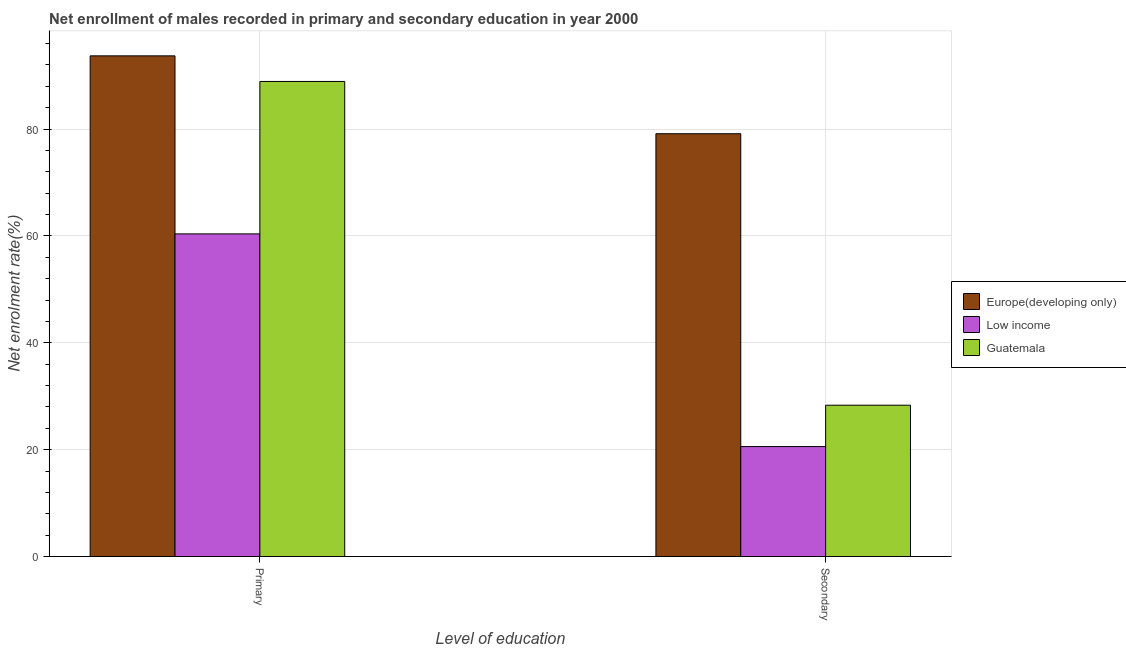Are the number of bars on each tick of the X-axis equal?
Make the answer very short. Yes. How many bars are there on the 1st tick from the left?
Provide a succinct answer. 3. How many bars are there on the 2nd tick from the right?
Provide a succinct answer. 3. What is the label of the 2nd group of bars from the left?
Give a very brief answer. Secondary. What is the enrollment rate in secondary education in Europe(developing only)?
Your response must be concise. 79.12. Across all countries, what is the maximum enrollment rate in primary education?
Offer a very short reply. 93.69. Across all countries, what is the minimum enrollment rate in primary education?
Offer a very short reply. 60.37. In which country was the enrollment rate in secondary education maximum?
Your response must be concise. Europe(developing only). What is the total enrollment rate in primary education in the graph?
Provide a succinct answer. 242.96. What is the difference between the enrollment rate in primary education in Europe(developing only) and that in Low income?
Provide a succinct answer. 33.31. What is the difference between the enrollment rate in primary education in Guatemala and the enrollment rate in secondary education in Low income?
Provide a succinct answer. 68.32. What is the average enrollment rate in primary education per country?
Your response must be concise. 80.99. What is the difference between the enrollment rate in primary education and enrollment rate in secondary education in Guatemala?
Offer a terse response. 60.58. In how many countries, is the enrollment rate in secondary education greater than 56 %?
Keep it short and to the point. 1. What is the ratio of the enrollment rate in primary education in Guatemala to that in Low income?
Make the answer very short. 1.47. Is the enrollment rate in primary education in Low income less than that in Europe(developing only)?
Provide a succinct answer. Yes. What does the 3rd bar from the left in Secondary represents?
Your answer should be very brief. Guatemala. What does the 3rd bar from the right in Secondary represents?
Offer a very short reply. Europe(developing only). How many bars are there?
Your answer should be very brief. 6. Are all the bars in the graph horizontal?
Provide a succinct answer. No. How many countries are there in the graph?
Provide a short and direct response. 3. Does the graph contain grids?
Your response must be concise. Yes. What is the title of the graph?
Your answer should be very brief. Net enrollment of males recorded in primary and secondary education in year 2000. What is the label or title of the X-axis?
Offer a terse response. Level of education. What is the label or title of the Y-axis?
Give a very brief answer. Net enrolment rate(%). What is the Net enrolment rate(%) of Europe(developing only) in Primary?
Offer a terse response. 93.69. What is the Net enrolment rate(%) in Low income in Primary?
Make the answer very short. 60.37. What is the Net enrolment rate(%) of Guatemala in Primary?
Give a very brief answer. 88.9. What is the Net enrolment rate(%) in Europe(developing only) in Secondary?
Provide a short and direct response. 79.12. What is the Net enrolment rate(%) of Low income in Secondary?
Make the answer very short. 20.57. What is the Net enrolment rate(%) in Guatemala in Secondary?
Provide a short and direct response. 28.31. Across all Level of education, what is the maximum Net enrolment rate(%) in Europe(developing only)?
Your answer should be compact. 93.69. Across all Level of education, what is the maximum Net enrolment rate(%) of Low income?
Your response must be concise. 60.37. Across all Level of education, what is the maximum Net enrolment rate(%) in Guatemala?
Keep it short and to the point. 88.9. Across all Level of education, what is the minimum Net enrolment rate(%) in Europe(developing only)?
Give a very brief answer. 79.12. Across all Level of education, what is the minimum Net enrolment rate(%) in Low income?
Your answer should be very brief. 20.57. Across all Level of education, what is the minimum Net enrolment rate(%) in Guatemala?
Provide a succinct answer. 28.31. What is the total Net enrolment rate(%) in Europe(developing only) in the graph?
Give a very brief answer. 172.8. What is the total Net enrolment rate(%) of Low income in the graph?
Your answer should be very brief. 80.95. What is the total Net enrolment rate(%) of Guatemala in the graph?
Make the answer very short. 117.21. What is the difference between the Net enrolment rate(%) in Europe(developing only) in Primary and that in Secondary?
Provide a succinct answer. 14.57. What is the difference between the Net enrolment rate(%) in Low income in Primary and that in Secondary?
Offer a very short reply. 39.8. What is the difference between the Net enrolment rate(%) in Guatemala in Primary and that in Secondary?
Provide a succinct answer. 60.58. What is the difference between the Net enrolment rate(%) of Europe(developing only) in Primary and the Net enrolment rate(%) of Low income in Secondary?
Offer a terse response. 73.11. What is the difference between the Net enrolment rate(%) in Europe(developing only) in Primary and the Net enrolment rate(%) in Guatemala in Secondary?
Your response must be concise. 65.37. What is the difference between the Net enrolment rate(%) in Low income in Primary and the Net enrolment rate(%) in Guatemala in Secondary?
Make the answer very short. 32.06. What is the average Net enrolment rate(%) in Europe(developing only) per Level of education?
Keep it short and to the point. 86.4. What is the average Net enrolment rate(%) of Low income per Level of education?
Ensure brevity in your answer.  40.47. What is the average Net enrolment rate(%) in Guatemala per Level of education?
Keep it short and to the point. 58.61. What is the difference between the Net enrolment rate(%) in Europe(developing only) and Net enrolment rate(%) in Low income in Primary?
Your response must be concise. 33.31. What is the difference between the Net enrolment rate(%) in Europe(developing only) and Net enrolment rate(%) in Guatemala in Primary?
Provide a succinct answer. 4.79. What is the difference between the Net enrolment rate(%) of Low income and Net enrolment rate(%) of Guatemala in Primary?
Provide a short and direct response. -28.52. What is the difference between the Net enrolment rate(%) of Europe(developing only) and Net enrolment rate(%) of Low income in Secondary?
Your response must be concise. 58.54. What is the difference between the Net enrolment rate(%) of Europe(developing only) and Net enrolment rate(%) of Guatemala in Secondary?
Your response must be concise. 50.8. What is the difference between the Net enrolment rate(%) in Low income and Net enrolment rate(%) in Guatemala in Secondary?
Give a very brief answer. -7.74. What is the ratio of the Net enrolment rate(%) of Europe(developing only) in Primary to that in Secondary?
Your answer should be compact. 1.18. What is the ratio of the Net enrolment rate(%) of Low income in Primary to that in Secondary?
Make the answer very short. 2.93. What is the ratio of the Net enrolment rate(%) in Guatemala in Primary to that in Secondary?
Keep it short and to the point. 3.14. What is the difference between the highest and the second highest Net enrolment rate(%) of Europe(developing only)?
Your answer should be compact. 14.57. What is the difference between the highest and the second highest Net enrolment rate(%) in Low income?
Provide a short and direct response. 39.8. What is the difference between the highest and the second highest Net enrolment rate(%) in Guatemala?
Keep it short and to the point. 60.58. What is the difference between the highest and the lowest Net enrolment rate(%) of Europe(developing only)?
Offer a very short reply. 14.57. What is the difference between the highest and the lowest Net enrolment rate(%) in Low income?
Ensure brevity in your answer.  39.8. What is the difference between the highest and the lowest Net enrolment rate(%) in Guatemala?
Provide a short and direct response. 60.58. 